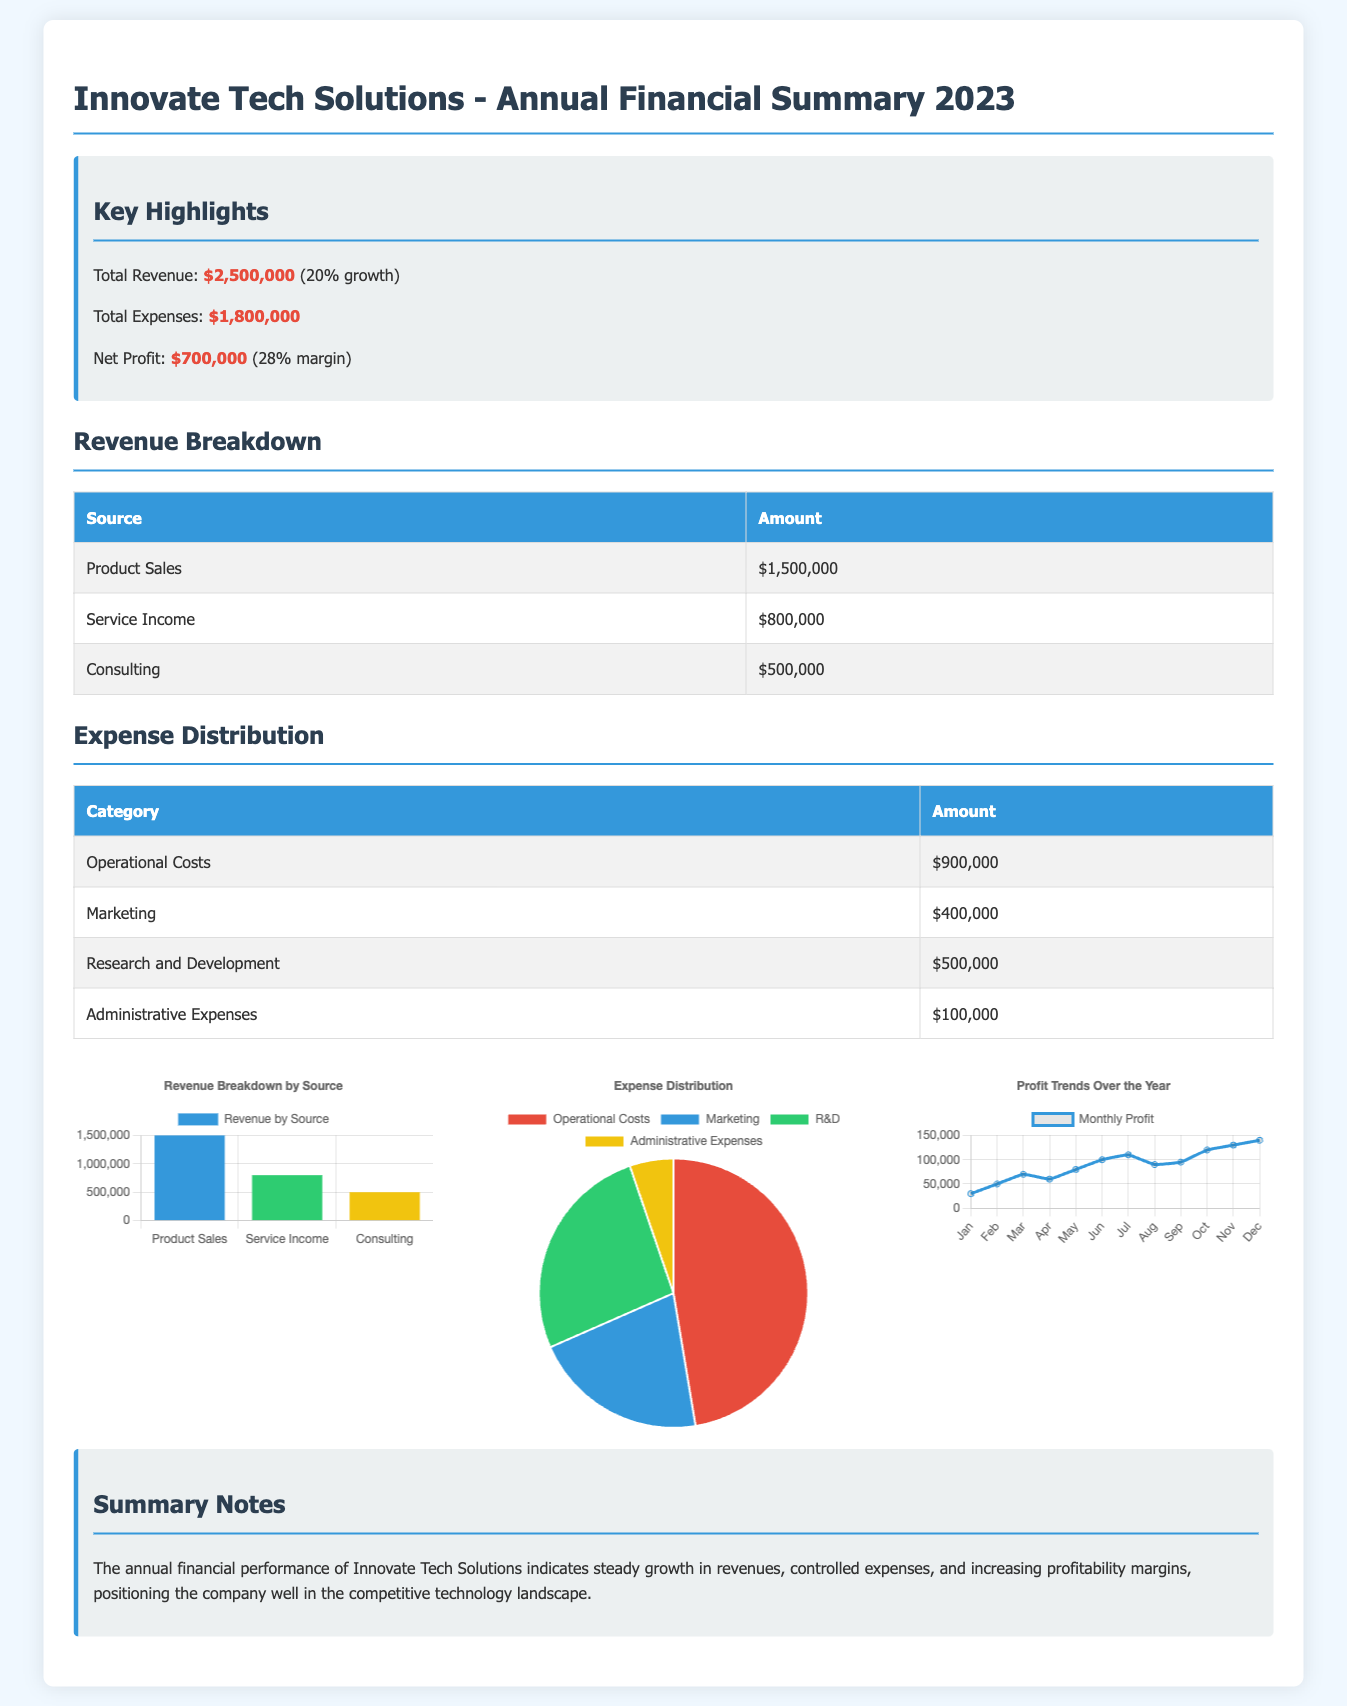What is the total revenue? The total revenue is highlighted in the document, showing a figure of 2,500,000 with a 20% growth.
Answer: $2,500,000 What are total expenses? The total expenses can be found in the summary box of the document, which states the amount is 1,800,000.
Answer: $1,800,000 What is the net profit margin? The net profit margin is calculated from the net profit of 700,000 and the total revenue, resulting in a margin of 28%.
Answer: 28% Which category has the highest expense? The expenses are categorized in a table, with Operational Costs shown as the highest at 900,000.
Answer: Operational Costs What is the revenue from Service Income? In the revenue breakdown table, the amount for Service Income is clearly stated as 800,000.
Answer: $800,000 How many sources contribute to the revenue? The revenue breakdown section lists three sources contributing to the total revenue.
Answer: 3 What month recorded the highest profit? The profit trend chart indicates the highest monthly profit occurred in December at 140,000.
Answer: December How much was spent on Research and Development? The expense distribution table shows the amount allocated to Research and Development at 500,000.
Answer: $500,000 What type of chart is used for expense distribution? The document contains a pie chart to visually represent the expense distribution among various categories.
Answer: Pie Chart 